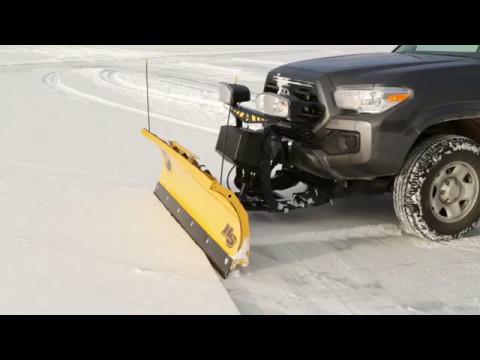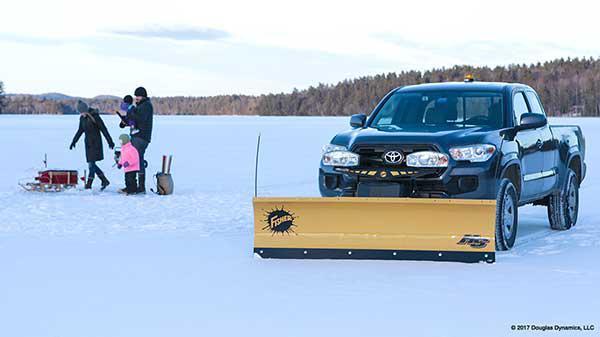The first image is the image on the left, the second image is the image on the right. Given the left and right images, does the statement "Left image shows a camera-facing vehicle plowing a snow-covered ground." hold true? Answer yes or no. No. 